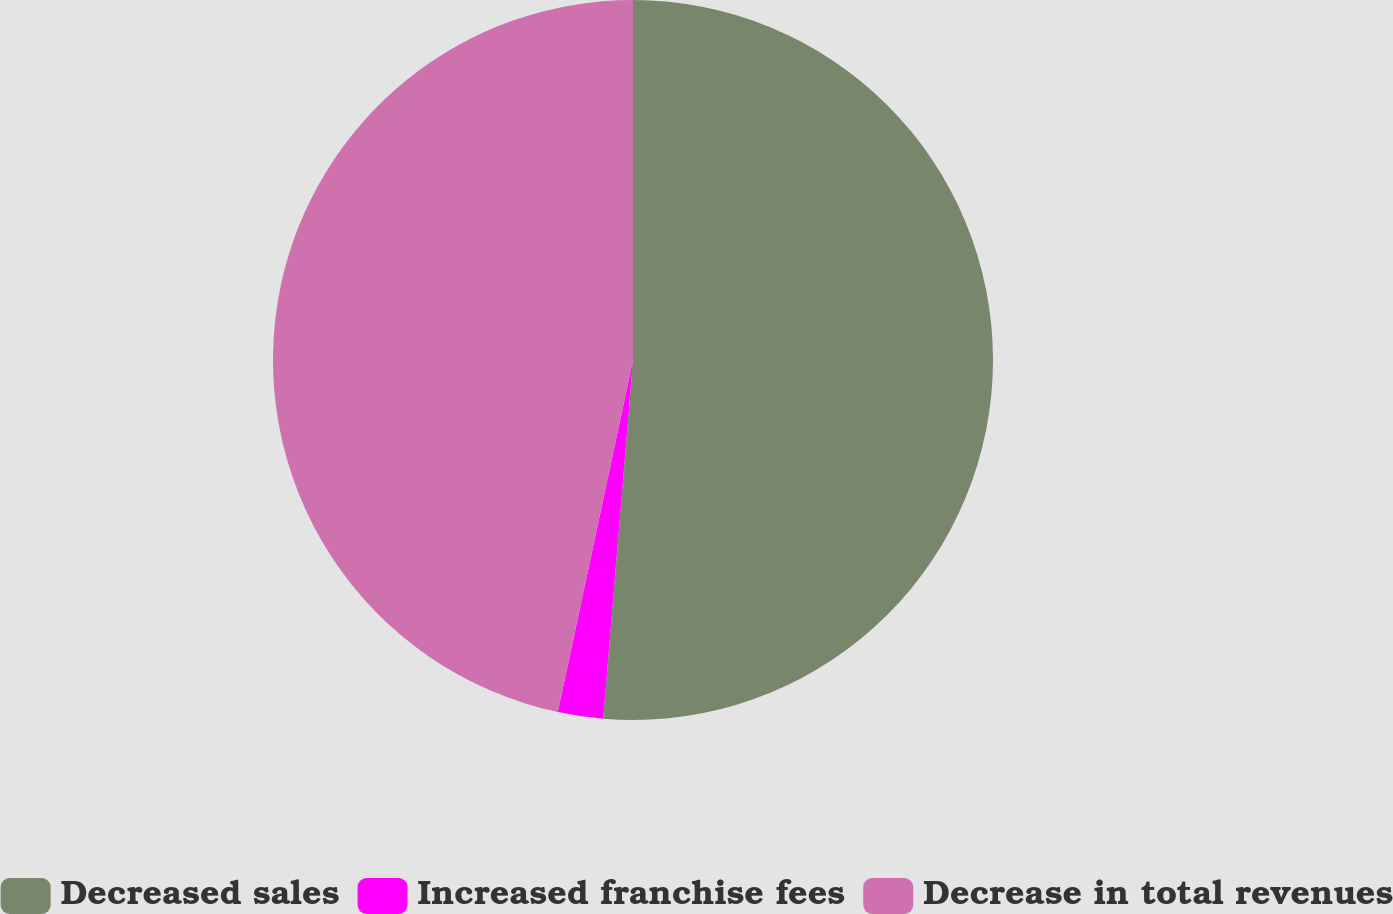Convert chart to OTSL. <chart><loc_0><loc_0><loc_500><loc_500><pie_chart><fcel>Decreased sales<fcel>Increased franchise fees<fcel>Decrease in total revenues<nl><fcel>51.32%<fcel>2.03%<fcel>46.65%<nl></chart> 